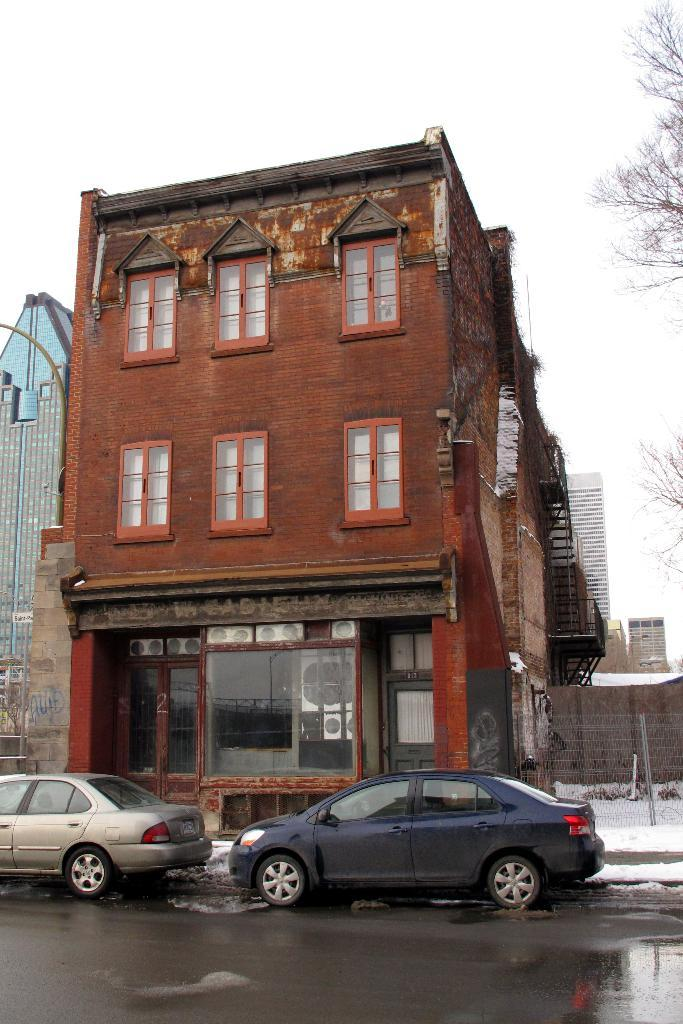What is the setting of the image? The image is an outside view. What can be seen beside the building in the image? There are two cars beside the building. Where is the building located in the image? The building is in the middle of the image. What is visible at the top of the image? The sky is visible at the top of the image. Where are the flowers planted in the image? There are no flowers present in the image. What type of potato can be seen growing beside the building? There is no potato visible in the image. 